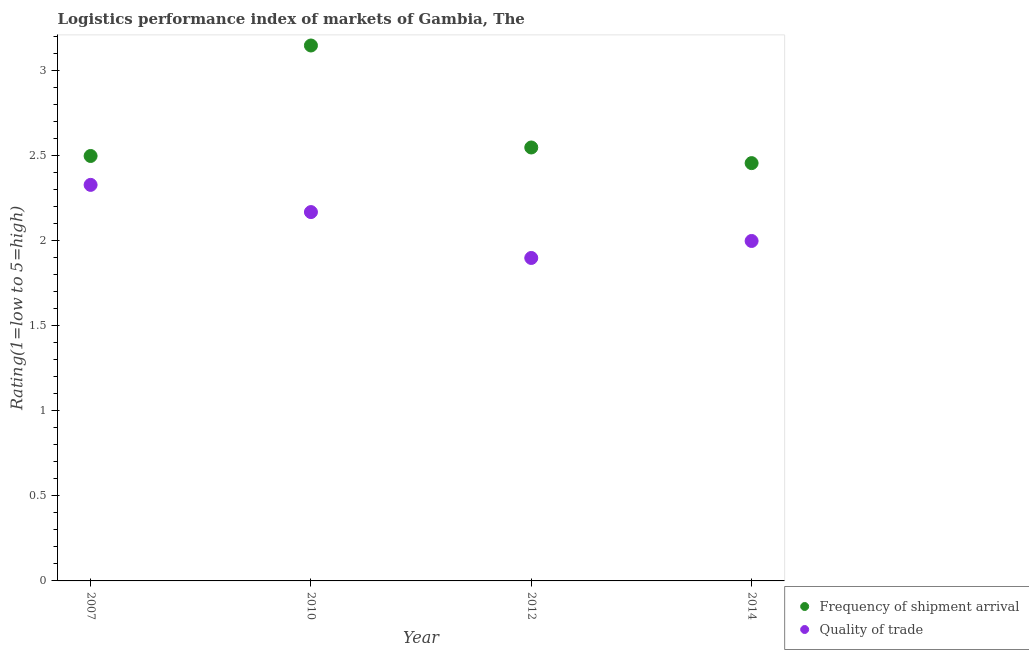Is the number of dotlines equal to the number of legend labels?
Provide a short and direct response. Yes. What is the lpi quality of trade in 2014?
Your answer should be compact. 2. Across all years, what is the maximum lpi of frequency of shipment arrival?
Ensure brevity in your answer.  3.15. Across all years, what is the minimum lpi of frequency of shipment arrival?
Keep it short and to the point. 2.46. In which year was the lpi of frequency of shipment arrival minimum?
Your answer should be very brief. 2014. What is the difference between the lpi of frequency of shipment arrival in 2012 and that in 2014?
Your answer should be very brief. 0.09. What is the difference between the lpi quality of trade in 2007 and the lpi of frequency of shipment arrival in 2014?
Provide a succinct answer. -0.13. What is the average lpi of frequency of shipment arrival per year?
Give a very brief answer. 2.66. In the year 2012, what is the difference between the lpi of frequency of shipment arrival and lpi quality of trade?
Your answer should be compact. 0.65. In how many years, is the lpi of frequency of shipment arrival greater than 0.2?
Offer a very short reply. 4. What is the ratio of the lpi quality of trade in 2007 to that in 2012?
Offer a terse response. 1.23. Is the lpi of frequency of shipment arrival in 2012 less than that in 2014?
Give a very brief answer. No. What is the difference between the highest and the second highest lpi of frequency of shipment arrival?
Provide a short and direct response. 0.6. What is the difference between the highest and the lowest lpi of frequency of shipment arrival?
Your response must be concise. 0.69. Does the lpi of frequency of shipment arrival monotonically increase over the years?
Your answer should be compact. No. Is the lpi quality of trade strictly greater than the lpi of frequency of shipment arrival over the years?
Your response must be concise. No. How many dotlines are there?
Offer a very short reply. 2. How many years are there in the graph?
Your answer should be very brief. 4. What is the difference between two consecutive major ticks on the Y-axis?
Keep it short and to the point. 0.5. Are the values on the major ticks of Y-axis written in scientific E-notation?
Provide a succinct answer. No. Where does the legend appear in the graph?
Your answer should be compact. Bottom right. How many legend labels are there?
Your answer should be very brief. 2. How are the legend labels stacked?
Ensure brevity in your answer.  Vertical. What is the title of the graph?
Offer a terse response. Logistics performance index of markets of Gambia, The. Does "Overweight" appear as one of the legend labels in the graph?
Provide a short and direct response. No. What is the label or title of the Y-axis?
Offer a very short reply. Rating(1=low to 5=high). What is the Rating(1=low to 5=high) in Frequency of shipment arrival in 2007?
Your response must be concise. 2.5. What is the Rating(1=low to 5=high) of Quality of trade in 2007?
Make the answer very short. 2.33. What is the Rating(1=low to 5=high) of Frequency of shipment arrival in 2010?
Your response must be concise. 3.15. What is the Rating(1=low to 5=high) in Quality of trade in 2010?
Give a very brief answer. 2.17. What is the Rating(1=low to 5=high) in Frequency of shipment arrival in 2012?
Provide a short and direct response. 2.55. What is the Rating(1=low to 5=high) of Frequency of shipment arrival in 2014?
Your response must be concise. 2.46. Across all years, what is the maximum Rating(1=low to 5=high) of Frequency of shipment arrival?
Your answer should be very brief. 3.15. Across all years, what is the maximum Rating(1=low to 5=high) of Quality of trade?
Your answer should be very brief. 2.33. Across all years, what is the minimum Rating(1=low to 5=high) in Frequency of shipment arrival?
Keep it short and to the point. 2.46. Across all years, what is the minimum Rating(1=low to 5=high) in Quality of trade?
Offer a terse response. 1.9. What is the total Rating(1=low to 5=high) of Frequency of shipment arrival in the graph?
Offer a very short reply. 10.66. What is the total Rating(1=low to 5=high) in Quality of trade in the graph?
Your answer should be very brief. 8.4. What is the difference between the Rating(1=low to 5=high) of Frequency of shipment arrival in 2007 and that in 2010?
Your response must be concise. -0.65. What is the difference between the Rating(1=low to 5=high) in Quality of trade in 2007 and that in 2010?
Give a very brief answer. 0.16. What is the difference between the Rating(1=low to 5=high) in Frequency of shipment arrival in 2007 and that in 2012?
Ensure brevity in your answer.  -0.05. What is the difference between the Rating(1=low to 5=high) of Quality of trade in 2007 and that in 2012?
Keep it short and to the point. 0.43. What is the difference between the Rating(1=low to 5=high) in Frequency of shipment arrival in 2007 and that in 2014?
Your answer should be compact. 0.04. What is the difference between the Rating(1=low to 5=high) in Quality of trade in 2007 and that in 2014?
Make the answer very short. 0.33. What is the difference between the Rating(1=low to 5=high) in Quality of trade in 2010 and that in 2012?
Your response must be concise. 0.27. What is the difference between the Rating(1=low to 5=high) of Frequency of shipment arrival in 2010 and that in 2014?
Offer a very short reply. 0.69. What is the difference between the Rating(1=low to 5=high) of Quality of trade in 2010 and that in 2014?
Offer a terse response. 0.17. What is the difference between the Rating(1=low to 5=high) in Frequency of shipment arrival in 2012 and that in 2014?
Offer a very short reply. 0.09. What is the difference between the Rating(1=low to 5=high) in Frequency of shipment arrival in 2007 and the Rating(1=low to 5=high) in Quality of trade in 2010?
Provide a succinct answer. 0.33. What is the difference between the Rating(1=low to 5=high) in Frequency of shipment arrival in 2007 and the Rating(1=low to 5=high) in Quality of trade in 2012?
Ensure brevity in your answer.  0.6. What is the difference between the Rating(1=low to 5=high) of Frequency of shipment arrival in 2010 and the Rating(1=low to 5=high) of Quality of trade in 2012?
Keep it short and to the point. 1.25. What is the difference between the Rating(1=low to 5=high) of Frequency of shipment arrival in 2010 and the Rating(1=low to 5=high) of Quality of trade in 2014?
Your answer should be compact. 1.15. What is the difference between the Rating(1=low to 5=high) of Frequency of shipment arrival in 2012 and the Rating(1=low to 5=high) of Quality of trade in 2014?
Your answer should be very brief. 0.55. What is the average Rating(1=low to 5=high) of Frequency of shipment arrival per year?
Keep it short and to the point. 2.66. In the year 2007, what is the difference between the Rating(1=low to 5=high) in Frequency of shipment arrival and Rating(1=low to 5=high) in Quality of trade?
Offer a terse response. 0.17. In the year 2010, what is the difference between the Rating(1=low to 5=high) in Frequency of shipment arrival and Rating(1=low to 5=high) in Quality of trade?
Offer a terse response. 0.98. In the year 2012, what is the difference between the Rating(1=low to 5=high) in Frequency of shipment arrival and Rating(1=low to 5=high) in Quality of trade?
Offer a very short reply. 0.65. In the year 2014, what is the difference between the Rating(1=low to 5=high) in Frequency of shipment arrival and Rating(1=low to 5=high) in Quality of trade?
Keep it short and to the point. 0.46. What is the ratio of the Rating(1=low to 5=high) in Frequency of shipment arrival in 2007 to that in 2010?
Offer a terse response. 0.79. What is the ratio of the Rating(1=low to 5=high) in Quality of trade in 2007 to that in 2010?
Make the answer very short. 1.07. What is the ratio of the Rating(1=low to 5=high) of Frequency of shipment arrival in 2007 to that in 2012?
Give a very brief answer. 0.98. What is the ratio of the Rating(1=low to 5=high) in Quality of trade in 2007 to that in 2012?
Offer a very short reply. 1.23. What is the ratio of the Rating(1=low to 5=high) in Frequency of shipment arrival in 2007 to that in 2014?
Make the answer very short. 1.02. What is the ratio of the Rating(1=low to 5=high) in Quality of trade in 2007 to that in 2014?
Provide a short and direct response. 1.17. What is the ratio of the Rating(1=low to 5=high) in Frequency of shipment arrival in 2010 to that in 2012?
Offer a very short reply. 1.24. What is the ratio of the Rating(1=low to 5=high) in Quality of trade in 2010 to that in 2012?
Offer a terse response. 1.14. What is the ratio of the Rating(1=low to 5=high) of Frequency of shipment arrival in 2010 to that in 2014?
Offer a terse response. 1.28. What is the ratio of the Rating(1=low to 5=high) of Quality of trade in 2010 to that in 2014?
Make the answer very short. 1.08. What is the ratio of the Rating(1=low to 5=high) in Frequency of shipment arrival in 2012 to that in 2014?
Make the answer very short. 1.04. What is the ratio of the Rating(1=low to 5=high) of Quality of trade in 2012 to that in 2014?
Ensure brevity in your answer.  0.95. What is the difference between the highest and the second highest Rating(1=low to 5=high) in Frequency of shipment arrival?
Ensure brevity in your answer.  0.6. What is the difference between the highest and the second highest Rating(1=low to 5=high) in Quality of trade?
Your answer should be compact. 0.16. What is the difference between the highest and the lowest Rating(1=low to 5=high) in Frequency of shipment arrival?
Ensure brevity in your answer.  0.69. What is the difference between the highest and the lowest Rating(1=low to 5=high) of Quality of trade?
Your answer should be compact. 0.43. 